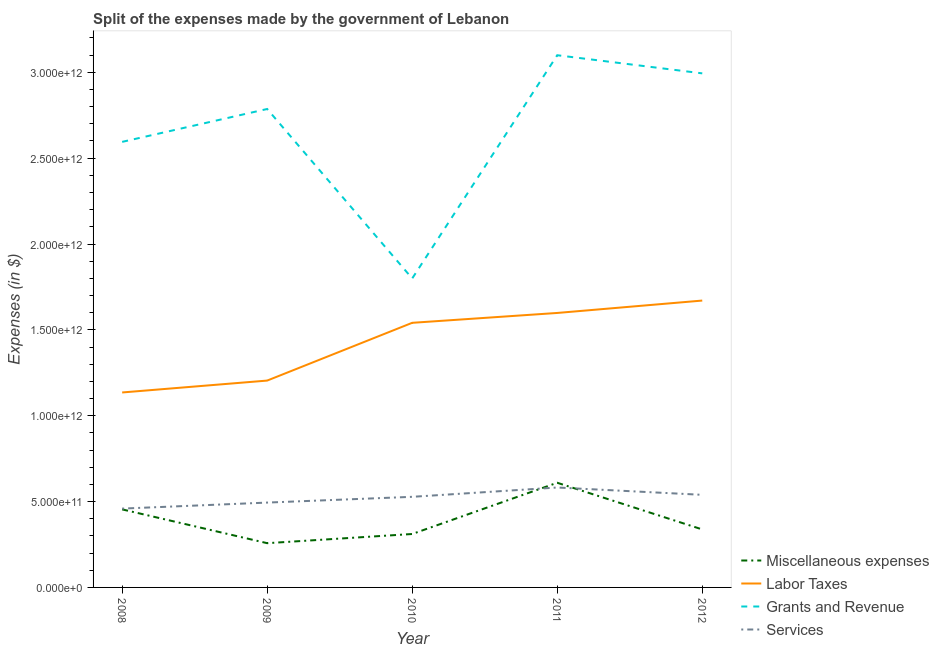Does the line corresponding to amount spent on miscellaneous expenses intersect with the line corresponding to amount spent on services?
Ensure brevity in your answer.  Yes. Is the number of lines equal to the number of legend labels?
Give a very brief answer. Yes. What is the amount spent on labor taxes in 2008?
Ensure brevity in your answer.  1.14e+12. Across all years, what is the maximum amount spent on grants and revenue?
Provide a short and direct response. 3.10e+12. Across all years, what is the minimum amount spent on miscellaneous expenses?
Keep it short and to the point. 2.58e+11. In which year was the amount spent on services maximum?
Provide a short and direct response. 2011. What is the total amount spent on services in the graph?
Offer a terse response. 2.60e+12. What is the difference between the amount spent on grants and revenue in 2009 and that in 2012?
Your response must be concise. -2.08e+11. What is the difference between the amount spent on grants and revenue in 2011 and the amount spent on labor taxes in 2010?
Provide a short and direct response. 1.56e+12. What is the average amount spent on labor taxes per year?
Your answer should be compact. 1.43e+12. In the year 2012, what is the difference between the amount spent on miscellaneous expenses and amount spent on grants and revenue?
Make the answer very short. -2.66e+12. In how many years, is the amount spent on labor taxes greater than 1900000000000 $?
Provide a short and direct response. 0. What is the ratio of the amount spent on grants and revenue in 2009 to that in 2012?
Your answer should be very brief. 0.93. Is the amount spent on grants and revenue in 2009 less than that in 2011?
Offer a very short reply. Yes. What is the difference between the highest and the second highest amount spent on services?
Make the answer very short. 4.27e+1. What is the difference between the highest and the lowest amount spent on labor taxes?
Offer a terse response. 5.35e+11. In how many years, is the amount spent on miscellaneous expenses greater than the average amount spent on miscellaneous expenses taken over all years?
Provide a succinct answer. 2. Is the sum of the amount spent on services in 2008 and 2010 greater than the maximum amount spent on grants and revenue across all years?
Provide a succinct answer. No. Is it the case that in every year, the sum of the amount spent on miscellaneous expenses and amount spent on services is greater than the sum of amount spent on labor taxes and amount spent on grants and revenue?
Your response must be concise. No. Does the amount spent on labor taxes monotonically increase over the years?
Your response must be concise. Yes. Is the amount spent on labor taxes strictly less than the amount spent on miscellaneous expenses over the years?
Your response must be concise. No. How many lines are there?
Offer a terse response. 4. What is the difference between two consecutive major ticks on the Y-axis?
Your answer should be compact. 5.00e+11. Are the values on the major ticks of Y-axis written in scientific E-notation?
Your response must be concise. Yes. Where does the legend appear in the graph?
Keep it short and to the point. Bottom right. How are the legend labels stacked?
Provide a short and direct response. Vertical. What is the title of the graph?
Provide a succinct answer. Split of the expenses made by the government of Lebanon. Does "Luxembourg" appear as one of the legend labels in the graph?
Keep it short and to the point. No. What is the label or title of the X-axis?
Provide a succinct answer. Year. What is the label or title of the Y-axis?
Offer a very short reply. Expenses (in $). What is the Expenses (in $) in Miscellaneous expenses in 2008?
Your response must be concise. 4.55e+11. What is the Expenses (in $) of Labor Taxes in 2008?
Your response must be concise. 1.14e+12. What is the Expenses (in $) in Grants and Revenue in 2008?
Provide a succinct answer. 2.59e+12. What is the Expenses (in $) in Services in 2008?
Make the answer very short. 4.59e+11. What is the Expenses (in $) of Miscellaneous expenses in 2009?
Offer a very short reply. 2.58e+11. What is the Expenses (in $) in Labor Taxes in 2009?
Provide a short and direct response. 1.20e+12. What is the Expenses (in $) in Grants and Revenue in 2009?
Provide a succinct answer. 2.79e+12. What is the Expenses (in $) in Services in 2009?
Ensure brevity in your answer.  4.94e+11. What is the Expenses (in $) in Miscellaneous expenses in 2010?
Offer a terse response. 3.11e+11. What is the Expenses (in $) of Labor Taxes in 2010?
Your answer should be very brief. 1.54e+12. What is the Expenses (in $) of Grants and Revenue in 2010?
Your answer should be compact. 1.80e+12. What is the Expenses (in $) of Services in 2010?
Ensure brevity in your answer.  5.28e+11. What is the Expenses (in $) in Miscellaneous expenses in 2011?
Your answer should be very brief. 6.10e+11. What is the Expenses (in $) in Labor Taxes in 2011?
Provide a succinct answer. 1.60e+12. What is the Expenses (in $) in Grants and Revenue in 2011?
Keep it short and to the point. 3.10e+12. What is the Expenses (in $) in Services in 2011?
Offer a very short reply. 5.82e+11. What is the Expenses (in $) of Miscellaneous expenses in 2012?
Make the answer very short. 3.38e+11. What is the Expenses (in $) of Labor Taxes in 2012?
Your answer should be compact. 1.67e+12. What is the Expenses (in $) of Grants and Revenue in 2012?
Make the answer very short. 2.99e+12. What is the Expenses (in $) in Services in 2012?
Your answer should be compact. 5.39e+11. Across all years, what is the maximum Expenses (in $) in Miscellaneous expenses?
Offer a very short reply. 6.10e+11. Across all years, what is the maximum Expenses (in $) of Labor Taxes?
Provide a short and direct response. 1.67e+12. Across all years, what is the maximum Expenses (in $) in Grants and Revenue?
Make the answer very short. 3.10e+12. Across all years, what is the maximum Expenses (in $) in Services?
Your answer should be compact. 5.82e+11. Across all years, what is the minimum Expenses (in $) in Miscellaneous expenses?
Provide a succinct answer. 2.58e+11. Across all years, what is the minimum Expenses (in $) in Labor Taxes?
Your response must be concise. 1.14e+12. Across all years, what is the minimum Expenses (in $) of Grants and Revenue?
Keep it short and to the point. 1.80e+12. Across all years, what is the minimum Expenses (in $) of Services?
Ensure brevity in your answer.  4.59e+11. What is the total Expenses (in $) of Miscellaneous expenses in the graph?
Make the answer very short. 1.97e+12. What is the total Expenses (in $) in Labor Taxes in the graph?
Provide a short and direct response. 7.15e+12. What is the total Expenses (in $) in Grants and Revenue in the graph?
Offer a very short reply. 1.33e+13. What is the total Expenses (in $) of Services in the graph?
Provide a succinct answer. 2.60e+12. What is the difference between the Expenses (in $) of Miscellaneous expenses in 2008 and that in 2009?
Ensure brevity in your answer.  1.97e+11. What is the difference between the Expenses (in $) of Labor Taxes in 2008 and that in 2009?
Provide a succinct answer. -6.92e+1. What is the difference between the Expenses (in $) of Grants and Revenue in 2008 and that in 2009?
Provide a succinct answer. -1.91e+11. What is the difference between the Expenses (in $) of Services in 2008 and that in 2009?
Your answer should be very brief. -3.50e+1. What is the difference between the Expenses (in $) of Miscellaneous expenses in 2008 and that in 2010?
Give a very brief answer. 1.43e+11. What is the difference between the Expenses (in $) of Labor Taxes in 2008 and that in 2010?
Ensure brevity in your answer.  -4.06e+11. What is the difference between the Expenses (in $) of Grants and Revenue in 2008 and that in 2010?
Ensure brevity in your answer.  7.95e+11. What is the difference between the Expenses (in $) of Services in 2008 and that in 2010?
Provide a succinct answer. -6.86e+1. What is the difference between the Expenses (in $) of Miscellaneous expenses in 2008 and that in 2011?
Your response must be concise. -1.55e+11. What is the difference between the Expenses (in $) of Labor Taxes in 2008 and that in 2011?
Your answer should be compact. -4.63e+11. What is the difference between the Expenses (in $) of Grants and Revenue in 2008 and that in 2011?
Your answer should be compact. -5.05e+11. What is the difference between the Expenses (in $) in Services in 2008 and that in 2011?
Your answer should be compact. -1.23e+11. What is the difference between the Expenses (in $) in Miscellaneous expenses in 2008 and that in 2012?
Your response must be concise. 1.17e+11. What is the difference between the Expenses (in $) of Labor Taxes in 2008 and that in 2012?
Keep it short and to the point. -5.35e+11. What is the difference between the Expenses (in $) of Grants and Revenue in 2008 and that in 2012?
Your answer should be very brief. -3.99e+11. What is the difference between the Expenses (in $) in Services in 2008 and that in 2012?
Provide a succinct answer. -8.02e+1. What is the difference between the Expenses (in $) of Miscellaneous expenses in 2009 and that in 2010?
Your answer should be compact. -5.34e+1. What is the difference between the Expenses (in $) of Labor Taxes in 2009 and that in 2010?
Ensure brevity in your answer.  -3.36e+11. What is the difference between the Expenses (in $) of Grants and Revenue in 2009 and that in 2010?
Your answer should be compact. 9.87e+11. What is the difference between the Expenses (in $) of Services in 2009 and that in 2010?
Ensure brevity in your answer.  -3.36e+1. What is the difference between the Expenses (in $) of Miscellaneous expenses in 2009 and that in 2011?
Ensure brevity in your answer.  -3.52e+11. What is the difference between the Expenses (in $) of Labor Taxes in 2009 and that in 2011?
Your response must be concise. -3.94e+11. What is the difference between the Expenses (in $) of Grants and Revenue in 2009 and that in 2011?
Offer a very short reply. -3.13e+11. What is the difference between the Expenses (in $) in Services in 2009 and that in 2011?
Make the answer very short. -8.78e+1. What is the difference between the Expenses (in $) in Miscellaneous expenses in 2009 and that in 2012?
Your answer should be compact. -8.01e+1. What is the difference between the Expenses (in $) in Labor Taxes in 2009 and that in 2012?
Make the answer very short. -4.66e+11. What is the difference between the Expenses (in $) of Grants and Revenue in 2009 and that in 2012?
Offer a very short reply. -2.08e+11. What is the difference between the Expenses (in $) of Services in 2009 and that in 2012?
Your answer should be compact. -4.52e+1. What is the difference between the Expenses (in $) of Miscellaneous expenses in 2010 and that in 2011?
Provide a succinct answer. -2.98e+11. What is the difference between the Expenses (in $) of Labor Taxes in 2010 and that in 2011?
Provide a succinct answer. -5.74e+1. What is the difference between the Expenses (in $) of Grants and Revenue in 2010 and that in 2011?
Your answer should be compact. -1.30e+12. What is the difference between the Expenses (in $) of Services in 2010 and that in 2011?
Ensure brevity in your answer.  -5.43e+1. What is the difference between the Expenses (in $) of Miscellaneous expenses in 2010 and that in 2012?
Provide a succinct answer. -2.66e+1. What is the difference between the Expenses (in $) in Labor Taxes in 2010 and that in 2012?
Ensure brevity in your answer.  -1.30e+11. What is the difference between the Expenses (in $) of Grants and Revenue in 2010 and that in 2012?
Offer a terse response. -1.19e+12. What is the difference between the Expenses (in $) in Services in 2010 and that in 2012?
Your response must be concise. -1.16e+1. What is the difference between the Expenses (in $) of Miscellaneous expenses in 2011 and that in 2012?
Keep it short and to the point. 2.72e+11. What is the difference between the Expenses (in $) in Labor Taxes in 2011 and that in 2012?
Your answer should be compact. -7.22e+1. What is the difference between the Expenses (in $) of Grants and Revenue in 2011 and that in 2012?
Make the answer very short. 1.06e+11. What is the difference between the Expenses (in $) in Services in 2011 and that in 2012?
Provide a short and direct response. 4.27e+1. What is the difference between the Expenses (in $) in Miscellaneous expenses in 2008 and the Expenses (in $) in Labor Taxes in 2009?
Keep it short and to the point. -7.50e+11. What is the difference between the Expenses (in $) of Miscellaneous expenses in 2008 and the Expenses (in $) of Grants and Revenue in 2009?
Offer a terse response. -2.33e+12. What is the difference between the Expenses (in $) of Miscellaneous expenses in 2008 and the Expenses (in $) of Services in 2009?
Offer a terse response. -3.96e+1. What is the difference between the Expenses (in $) in Labor Taxes in 2008 and the Expenses (in $) in Grants and Revenue in 2009?
Your answer should be very brief. -1.65e+12. What is the difference between the Expenses (in $) in Labor Taxes in 2008 and the Expenses (in $) in Services in 2009?
Your answer should be compact. 6.41e+11. What is the difference between the Expenses (in $) in Grants and Revenue in 2008 and the Expenses (in $) in Services in 2009?
Your answer should be very brief. 2.10e+12. What is the difference between the Expenses (in $) of Miscellaneous expenses in 2008 and the Expenses (in $) of Labor Taxes in 2010?
Your response must be concise. -1.09e+12. What is the difference between the Expenses (in $) of Miscellaneous expenses in 2008 and the Expenses (in $) of Grants and Revenue in 2010?
Your answer should be compact. -1.34e+12. What is the difference between the Expenses (in $) of Miscellaneous expenses in 2008 and the Expenses (in $) of Services in 2010?
Make the answer very short. -7.32e+1. What is the difference between the Expenses (in $) in Labor Taxes in 2008 and the Expenses (in $) in Grants and Revenue in 2010?
Make the answer very short. -6.64e+11. What is the difference between the Expenses (in $) of Labor Taxes in 2008 and the Expenses (in $) of Services in 2010?
Your answer should be very brief. 6.08e+11. What is the difference between the Expenses (in $) in Grants and Revenue in 2008 and the Expenses (in $) in Services in 2010?
Offer a very short reply. 2.07e+12. What is the difference between the Expenses (in $) of Miscellaneous expenses in 2008 and the Expenses (in $) of Labor Taxes in 2011?
Provide a short and direct response. -1.14e+12. What is the difference between the Expenses (in $) in Miscellaneous expenses in 2008 and the Expenses (in $) in Grants and Revenue in 2011?
Ensure brevity in your answer.  -2.65e+12. What is the difference between the Expenses (in $) in Miscellaneous expenses in 2008 and the Expenses (in $) in Services in 2011?
Provide a succinct answer. -1.27e+11. What is the difference between the Expenses (in $) of Labor Taxes in 2008 and the Expenses (in $) of Grants and Revenue in 2011?
Make the answer very short. -1.96e+12. What is the difference between the Expenses (in $) of Labor Taxes in 2008 and the Expenses (in $) of Services in 2011?
Offer a terse response. 5.53e+11. What is the difference between the Expenses (in $) in Grants and Revenue in 2008 and the Expenses (in $) in Services in 2011?
Keep it short and to the point. 2.01e+12. What is the difference between the Expenses (in $) in Miscellaneous expenses in 2008 and the Expenses (in $) in Labor Taxes in 2012?
Provide a short and direct response. -1.22e+12. What is the difference between the Expenses (in $) in Miscellaneous expenses in 2008 and the Expenses (in $) in Grants and Revenue in 2012?
Offer a terse response. -2.54e+12. What is the difference between the Expenses (in $) in Miscellaneous expenses in 2008 and the Expenses (in $) in Services in 2012?
Your answer should be compact. -8.48e+1. What is the difference between the Expenses (in $) in Labor Taxes in 2008 and the Expenses (in $) in Grants and Revenue in 2012?
Provide a succinct answer. -1.86e+12. What is the difference between the Expenses (in $) in Labor Taxes in 2008 and the Expenses (in $) in Services in 2012?
Provide a short and direct response. 5.96e+11. What is the difference between the Expenses (in $) in Grants and Revenue in 2008 and the Expenses (in $) in Services in 2012?
Ensure brevity in your answer.  2.06e+12. What is the difference between the Expenses (in $) in Miscellaneous expenses in 2009 and the Expenses (in $) in Labor Taxes in 2010?
Make the answer very short. -1.28e+12. What is the difference between the Expenses (in $) in Miscellaneous expenses in 2009 and the Expenses (in $) in Grants and Revenue in 2010?
Keep it short and to the point. -1.54e+12. What is the difference between the Expenses (in $) in Miscellaneous expenses in 2009 and the Expenses (in $) in Services in 2010?
Your response must be concise. -2.70e+11. What is the difference between the Expenses (in $) of Labor Taxes in 2009 and the Expenses (in $) of Grants and Revenue in 2010?
Ensure brevity in your answer.  -5.95e+11. What is the difference between the Expenses (in $) of Labor Taxes in 2009 and the Expenses (in $) of Services in 2010?
Provide a short and direct response. 6.77e+11. What is the difference between the Expenses (in $) of Grants and Revenue in 2009 and the Expenses (in $) of Services in 2010?
Ensure brevity in your answer.  2.26e+12. What is the difference between the Expenses (in $) in Miscellaneous expenses in 2009 and the Expenses (in $) in Labor Taxes in 2011?
Your response must be concise. -1.34e+12. What is the difference between the Expenses (in $) in Miscellaneous expenses in 2009 and the Expenses (in $) in Grants and Revenue in 2011?
Provide a succinct answer. -2.84e+12. What is the difference between the Expenses (in $) of Miscellaneous expenses in 2009 and the Expenses (in $) of Services in 2011?
Your response must be concise. -3.24e+11. What is the difference between the Expenses (in $) of Labor Taxes in 2009 and the Expenses (in $) of Grants and Revenue in 2011?
Your answer should be very brief. -1.89e+12. What is the difference between the Expenses (in $) of Labor Taxes in 2009 and the Expenses (in $) of Services in 2011?
Provide a succinct answer. 6.23e+11. What is the difference between the Expenses (in $) in Grants and Revenue in 2009 and the Expenses (in $) in Services in 2011?
Offer a very short reply. 2.20e+12. What is the difference between the Expenses (in $) in Miscellaneous expenses in 2009 and the Expenses (in $) in Labor Taxes in 2012?
Ensure brevity in your answer.  -1.41e+12. What is the difference between the Expenses (in $) in Miscellaneous expenses in 2009 and the Expenses (in $) in Grants and Revenue in 2012?
Ensure brevity in your answer.  -2.74e+12. What is the difference between the Expenses (in $) in Miscellaneous expenses in 2009 and the Expenses (in $) in Services in 2012?
Provide a succinct answer. -2.82e+11. What is the difference between the Expenses (in $) in Labor Taxes in 2009 and the Expenses (in $) in Grants and Revenue in 2012?
Your answer should be compact. -1.79e+12. What is the difference between the Expenses (in $) in Labor Taxes in 2009 and the Expenses (in $) in Services in 2012?
Your response must be concise. 6.65e+11. What is the difference between the Expenses (in $) in Grants and Revenue in 2009 and the Expenses (in $) in Services in 2012?
Your answer should be very brief. 2.25e+12. What is the difference between the Expenses (in $) in Miscellaneous expenses in 2010 and the Expenses (in $) in Labor Taxes in 2011?
Provide a succinct answer. -1.29e+12. What is the difference between the Expenses (in $) in Miscellaneous expenses in 2010 and the Expenses (in $) in Grants and Revenue in 2011?
Provide a short and direct response. -2.79e+12. What is the difference between the Expenses (in $) in Miscellaneous expenses in 2010 and the Expenses (in $) in Services in 2011?
Your response must be concise. -2.71e+11. What is the difference between the Expenses (in $) in Labor Taxes in 2010 and the Expenses (in $) in Grants and Revenue in 2011?
Your answer should be very brief. -1.56e+12. What is the difference between the Expenses (in $) of Labor Taxes in 2010 and the Expenses (in $) of Services in 2011?
Your response must be concise. 9.59e+11. What is the difference between the Expenses (in $) in Grants and Revenue in 2010 and the Expenses (in $) in Services in 2011?
Your response must be concise. 1.22e+12. What is the difference between the Expenses (in $) in Miscellaneous expenses in 2010 and the Expenses (in $) in Labor Taxes in 2012?
Offer a very short reply. -1.36e+12. What is the difference between the Expenses (in $) in Miscellaneous expenses in 2010 and the Expenses (in $) in Grants and Revenue in 2012?
Provide a succinct answer. -2.68e+12. What is the difference between the Expenses (in $) of Miscellaneous expenses in 2010 and the Expenses (in $) of Services in 2012?
Your answer should be compact. -2.28e+11. What is the difference between the Expenses (in $) in Labor Taxes in 2010 and the Expenses (in $) in Grants and Revenue in 2012?
Your answer should be compact. -1.45e+12. What is the difference between the Expenses (in $) of Labor Taxes in 2010 and the Expenses (in $) of Services in 2012?
Provide a succinct answer. 1.00e+12. What is the difference between the Expenses (in $) of Grants and Revenue in 2010 and the Expenses (in $) of Services in 2012?
Provide a short and direct response. 1.26e+12. What is the difference between the Expenses (in $) in Miscellaneous expenses in 2011 and the Expenses (in $) in Labor Taxes in 2012?
Provide a succinct answer. -1.06e+12. What is the difference between the Expenses (in $) of Miscellaneous expenses in 2011 and the Expenses (in $) of Grants and Revenue in 2012?
Provide a short and direct response. -2.38e+12. What is the difference between the Expenses (in $) in Miscellaneous expenses in 2011 and the Expenses (in $) in Services in 2012?
Your response must be concise. 7.03e+1. What is the difference between the Expenses (in $) of Labor Taxes in 2011 and the Expenses (in $) of Grants and Revenue in 2012?
Provide a short and direct response. -1.40e+12. What is the difference between the Expenses (in $) of Labor Taxes in 2011 and the Expenses (in $) of Services in 2012?
Offer a terse response. 1.06e+12. What is the difference between the Expenses (in $) in Grants and Revenue in 2011 and the Expenses (in $) in Services in 2012?
Make the answer very short. 2.56e+12. What is the average Expenses (in $) of Miscellaneous expenses per year?
Make the answer very short. 3.94e+11. What is the average Expenses (in $) of Labor Taxes per year?
Offer a terse response. 1.43e+12. What is the average Expenses (in $) in Grants and Revenue per year?
Your answer should be very brief. 2.65e+12. What is the average Expenses (in $) in Services per year?
Your response must be concise. 5.20e+11. In the year 2008, what is the difference between the Expenses (in $) of Miscellaneous expenses and Expenses (in $) of Labor Taxes?
Give a very brief answer. -6.81e+11. In the year 2008, what is the difference between the Expenses (in $) in Miscellaneous expenses and Expenses (in $) in Grants and Revenue?
Make the answer very short. -2.14e+12. In the year 2008, what is the difference between the Expenses (in $) in Miscellaneous expenses and Expenses (in $) in Services?
Offer a very short reply. -4.56e+09. In the year 2008, what is the difference between the Expenses (in $) in Labor Taxes and Expenses (in $) in Grants and Revenue?
Your response must be concise. -1.46e+12. In the year 2008, what is the difference between the Expenses (in $) in Labor Taxes and Expenses (in $) in Services?
Ensure brevity in your answer.  6.76e+11. In the year 2008, what is the difference between the Expenses (in $) of Grants and Revenue and Expenses (in $) of Services?
Ensure brevity in your answer.  2.14e+12. In the year 2009, what is the difference between the Expenses (in $) of Miscellaneous expenses and Expenses (in $) of Labor Taxes?
Ensure brevity in your answer.  -9.47e+11. In the year 2009, what is the difference between the Expenses (in $) in Miscellaneous expenses and Expenses (in $) in Grants and Revenue?
Your answer should be very brief. -2.53e+12. In the year 2009, what is the difference between the Expenses (in $) of Miscellaneous expenses and Expenses (in $) of Services?
Your response must be concise. -2.36e+11. In the year 2009, what is the difference between the Expenses (in $) of Labor Taxes and Expenses (in $) of Grants and Revenue?
Offer a very short reply. -1.58e+12. In the year 2009, what is the difference between the Expenses (in $) in Labor Taxes and Expenses (in $) in Services?
Your answer should be compact. 7.11e+11. In the year 2009, what is the difference between the Expenses (in $) in Grants and Revenue and Expenses (in $) in Services?
Ensure brevity in your answer.  2.29e+12. In the year 2010, what is the difference between the Expenses (in $) of Miscellaneous expenses and Expenses (in $) of Labor Taxes?
Keep it short and to the point. -1.23e+12. In the year 2010, what is the difference between the Expenses (in $) of Miscellaneous expenses and Expenses (in $) of Grants and Revenue?
Provide a succinct answer. -1.49e+12. In the year 2010, what is the difference between the Expenses (in $) of Miscellaneous expenses and Expenses (in $) of Services?
Ensure brevity in your answer.  -2.17e+11. In the year 2010, what is the difference between the Expenses (in $) in Labor Taxes and Expenses (in $) in Grants and Revenue?
Offer a very short reply. -2.58e+11. In the year 2010, what is the difference between the Expenses (in $) in Labor Taxes and Expenses (in $) in Services?
Your answer should be compact. 1.01e+12. In the year 2010, what is the difference between the Expenses (in $) in Grants and Revenue and Expenses (in $) in Services?
Provide a short and direct response. 1.27e+12. In the year 2011, what is the difference between the Expenses (in $) in Miscellaneous expenses and Expenses (in $) in Labor Taxes?
Offer a terse response. -9.89e+11. In the year 2011, what is the difference between the Expenses (in $) in Miscellaneous expenses and Expenses (in $) in Grants and Revenue?
Give a very brief answer. -2.49e+12. In the year 2011, what is the difference between the Expenses (in $) in Miscellaneous expenses and Expenses (in $) in Services?
Provide a short and direct response. 2.76e+1. In the year 2011, what is the difference between the Expenses (in $) of Labor Taxes and Expenses (in $) of Grants and Revenue?
Your answer should be compact. -1.50e+12. In the year 2011, what is the difference between the Expenses (in $) in Labor Taxes and Expenses (in $) in Services?
Make the answer very short. 1.02e+12. In the year 2011, what is the difference between the Expenses (in $) in Grants and Revenue and Expenses (in $) in Services?
Your response must be concise. 2.52e+12. In the year 2012, what is the difference between the Expenses (in $) in Miscellaneous expenses and Expenses (in $) in Labor Taxes?
Your answer should be compact. -1.33e+12. In the year 2012, what is the difference between the Expenses (in $) in Miscellaneous expenses and Expenses (in $) in Grants and Revenue?
Offer a terse response. -2.66e+12. In the year 2012, what is the difference between the Expenses (in $) of Miscellaneous expenses and Expenses (in $) of Services?
Ensure brevity in your answer.  -2.02e+11. In the year 2012, what is the difference between the Expenses (in $) in Labor Taxes and Expenses (in $) in Grants and Revenue?
Your answer should be very brief. -1.32e+12. In the year 2012, what is the difference between the Expenses (in $) in Labor Taxes and Expenses (in $) in Services?
Offer a very short reply. 1.13e+12. In the year 2012, what is the difference between the Expenses (in $) of Grants and Revenue and Expenses (in $) of Services?
Offer a very short reply. 2.45e+12. What is the ratio of the Expenses (in $) in Miscellaneous expenses in 2008 to that in 2009?
Provide a succinct answer. 1.76. What is the ratio of the Expenses (in $) of Labor Taxes in 2008 to that in 2009?
Keep it short and to the point. 0.94. What is the ratio of the Expenses (in $) of Grants and Revenue in 2008 to that in 2009?
Your answer should be very brief. 0.93. What is the ratio of the Expenses (in $) in Services in 2008 to that in 2009?
Offer a terse response. 0.93. What is the ratio of the Expenses (in $) in Miscellaneous expenses in 2008 to that in 2010?
Make the answer very short. 1.46. What is the ratio of the Expenses (in $) in Labor Taxes in 2008 to that in 2010?
Offer a very short reply. 0.74. What is the ratio of the Expenses (in $) in Grants and Revenue in 2008 to that in 2010?
Your answer should be compact. 1.44. What is the ratio of the Expenses (in $) of Services in 2008 to that in 2010?
Give a very brief answer. 0.87. What is the ratio of the Expenses (in $) in Miscellaneous expenses in 2008 to that in 2011?
Your answer should be very brief. 0.75. What is the ratio of the Expenses (in $) of Labor Taxes in 2008 to that in 2011?
Your answer should be very brief. 0.71. What is the ratio of the Expenses (in $) of Grants and Revenue in 2008 to that in 2011?
Ensure brevity in your answer.  0.84. What is the ratio of the Expenses (in $) in Services in 2008 to that in 2011?
Keep it short and to the point. 0.79. What is the ratio of the Expenses (in $) of Miscellaneous expenses in 2008 to that in 2012?
Your response must be concise. 1.35. What is the ratio of the Expenses (in $) of Labor Taxes in 2008 to that in 2012?
Your answer should be very brief. 0.68. What is the ratio of the Expenses (in $) of Grants and Revenue in 2008 to that in 2012?
Offer a terse response. 0.87. What is the ratio of the Expenses (in $) of Services in 2008 to that in 2012?
Provide a succinct answer. 0.85. What is the ratio of the Expenses (in $) in Miscellaneous expenses in 2009 to that in 2010?
Provide a short and direct response. 0.83. What is the ratio of the Expenses (in $) in Labor Taxes in 2009 to that in 2010?
Your answer should be very brief. 0.78. What is the ratio of the Expenses (in $) of Grants and Revenue in 2009 to that in 2010?
Your answer should be compact. 1.55. What is the ratio of the Expenses (in $) of Services in 2009 to that in 2010?
Offer a terse response. 0.94. What is the ratio of the Expenses (in $) in Miscellaneous expenses in 2009 to that in 2011?
Make the answer very short. 0.42. What is the ratio of the Expenses (in $) in Labor Taxes in 2009 to that in 2011?
Make the answer very short. 0.75. What is the ratio of the Expenses (in $) in Grants and Revenue in 2009 to that in 2011?
Offer a terse response. 0.9. What is the ratio of the Expenses (in $) of Services in 2009 to that in 2011?
Your response must be concise. 0.85. What is the ratio of the Expenses (in $) in Miscellaneous expenses in 2009 to that in 2012?
Give a very brief answer. 0.76. What is the ratio of the Expenses (in $) of Labor Taxes in 2009 to that in 2012?
Make the answer very short. 0.72. What is the ratio of the Expenses (in $) of Grants and Revenue in 2009 to that in 2012?
Ensure brevity in your answer.  0.93. What is the ratio of the Expenses (in $) of Services in 2009 to that in 2012?
Offer a terse response. 0.92. What is the ratio of the Expenses (in $) in Miscellaneous expenses in 2010 to that in 2011?
Ensure brevity in your answer.  0.51. What is the ratio of the Expenses (in $) of Labor Taxes in 2010 to that in 2011?
Your answer should be very brief. 0.96. What is the ratio of the Expenses (in $) in Grants and Revenue in 2010 to that in 2011?
Offer a terse response. 0.58. What is the ratio of the Expenses (in $) of Services in 2010 to that in 2011?
Offer a very short reply. 0.91. What is the ratio of the Expenses (in $) in Miscellaneous expenses in 2010 to that in 2012?
Offer a terse response. 0.92. What is the ratio of the Expenses (in $) in Labor Taxes in 2010 to that in 2012?
Your response must be concise. 0.92. What is the ratio of the Expenses (in $) of Grants and Revenue in 2010 to that in 2012?
Keep it short and to the point. 0.6. What is the ratio of the Expenses (in $) in Services in 2010 to that in 2012?
Make the answer very short. 0.98. What is the ratio of the Expenses (in $) of Miscellaneous expenses in 2011 to that in 2012?
Make the answer very short. 1.8. What is the ratio of the Expenses (in $) of Labor Taxes in 2011 to that in 2012?
Your answer should be compact. 0.96. What is the ratio of the Expenses (in $) of Grants and Revenue in 2011 to that in 2012?
Your answer should be very brief. 1.04. What is the ratio of the Expenses (in $) of Services in 2011 to that in 2012?
Make the answer very short. 1.08. What is the difference between the highest and the second highest Expenses (in $) in Miscellaneous expenses?
Your response must be concise. 1.55e+11. What is the difference between the highest and the second highest Expenses (in $) in Labor Taxes?
Give a very brief answer. 7.22e+1. What is the difference between the highest and the second highest Expenses (in $) in Grants and Revenue?
Make the answer very short. 1.06e+11. What is the difference between the highest and the second highest Expenses (in $) in Services?
Offer a terse response. 4.27e+1. What is the difference between the highest and the lowest Expenses (in $) in Miscellaneous expenses?
Provide a succinct answer. 3.52e+11. What is the difference between the highest and the lowest Expenses (in $) in Labor Taxes?
Offer a very short reply. 5.35e+11. What is the difference between the highest and the lowest Expenses (in $) of Grants and Revenue?
Your answer should be very brief. 1.30e+12. What is the difference between the highest and the lowest Expenses (in $) of Services?
Give a very brief answer. 1.23e+11. 